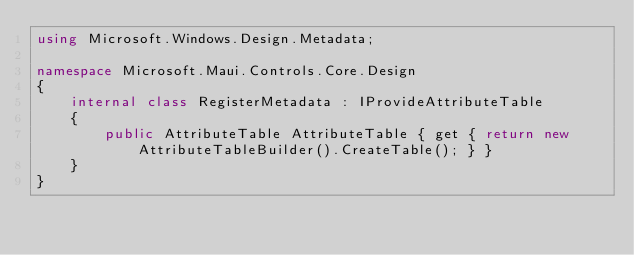Convert code to text. <code><loc_0><loc_0><loc_500><loc_500><_C#_>using Microsoft.Windows.Design.Metadata;

namespace Microsoft.Maui.Controls.Core.Design
{
	internal class RegisterMetadata : IProvideAttributeTable
	{
		public AttributeTable AttributeTable { get { return new AttributeTableBuilder().CreateTable(); } }
	}
}
</code> 